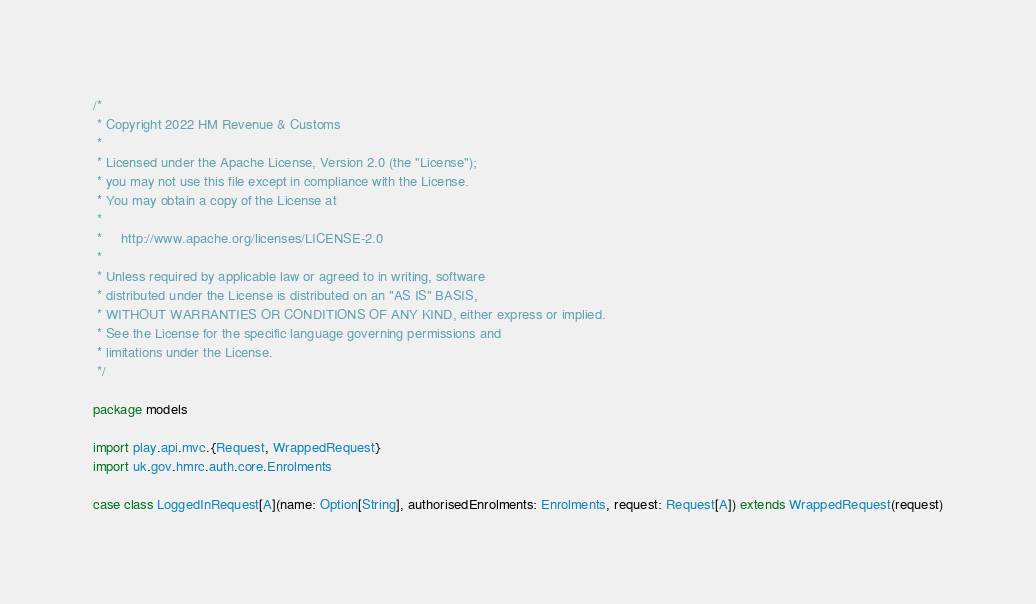<code> <loc_0><loc_0><loc_500><loc_500><_Scala_>/*
 * Copyright 2022 HM Revenue & Customs
 *
 * Licensed under the Apache License, Version 2.0 (the "License");
 * you may not use this file except in compliance with the License.
 * You may obtain a copy of the License at
 *
 *     http://www.apache.org/licenses/LICENSE-2.0
 *
 * Unless required by applicable law or agreed to in writing, software
 * distributed under the License is distributed on an "AS IS" BASIS,
 * WITHOUT WARRANTIES OR CONDITIONS OF ANY KIND, either express or implied.
 * See the License for the specific language governing permissions and
 * limitations under the License.
 */

package models

import play.api.mvc.{Request, WrappedRequest}
import uk.gov.hmrc.auth.core.Enrolments

case class LoggedInRequest[A](name: Option[String], authorisedEnrolments: Enrolments, request: Request[A]) extends WrappedRequest(request)
</code> 